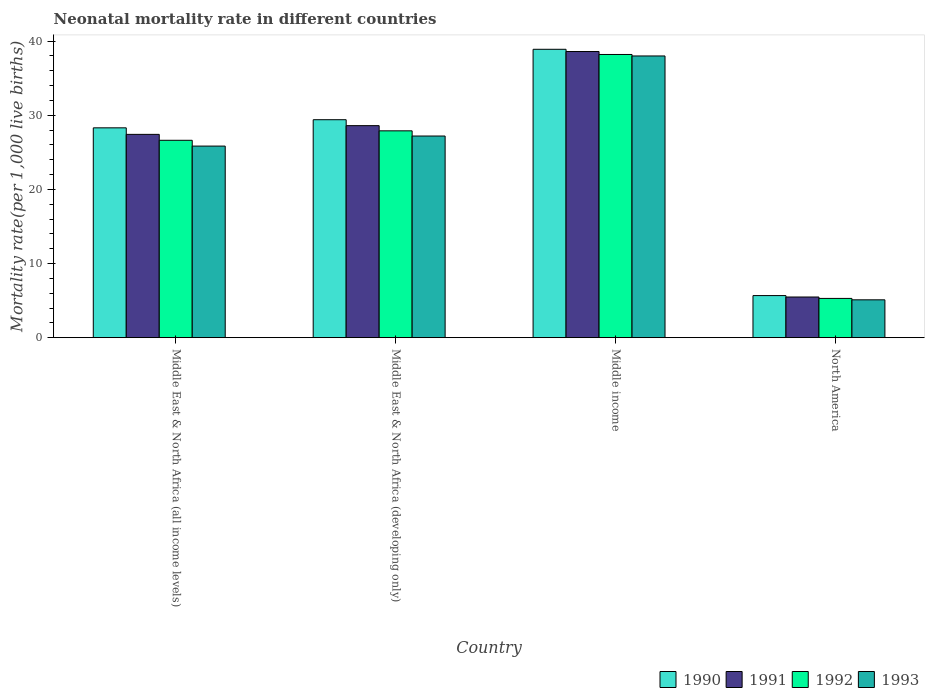How many different coloured bars are there?
Keep it short and to the point. 4. How many groups of bars are there?
Offer a very short reply. 4. Are the number of bars on each tick of the X-axis equal?
Ensure brevity in your answer.  Yes. How many bars are there on the 1st tick from the right?
Make the answer very short. 4. In how many cases, is the number of bars for a given country not equal to the number of legend labels?
Offer a very short reply. 0. What is the neonatal mortality rate in 1991 in Middle East & North Africa (developing only)?
Give a very brief answer. 28.6. Across all countries, what is the minimum neonatal mortality rate in 1992?
Your answer should be compact. 5.29. What is the total neonatal mortality rate in 1990 in the graph?
Offer a very short reply. 102.28. What is the difference between the neonatal mortality rate in 1992 in Middle East & North Africa (developing only) and that in Middle income?
Offer a terse response. -10.3. What is the difference between the neonatal mortality rate in 1990 in Middle East & North Africa (developing only) and the neonatal mortality rate in 1991 in North America?
Provide a short and direct response. 23.91. What is the average neonatal mortality rate in 1990 per country?
Offer a terse response. 25.57. What is the difference between the neonatal mortality rate of/in 1991 and neonatal mortality rate of/in 1993 in Middle East & North Africa (all income levels)?
Provide a short and direct response. 1.58. In how many countries, is the neonatal mortality rate in 1991 greater than 8?
Offer a very short reply. 3. What is the ratio of the neonatal mortality rate in 1991 in Middle East & North Africa (developing only) to that in North America?
Provide a succinct answer. 5.21. Is the neonatal mortality rate in 1991 in Middle East & North Africa (all income levels) less than that in Middle income?
Your answer should be compact. Yes. What is the difference between the highest and the second highest neonatal mortality rate in 1993?
Ensure brevity in your answer.  -1.36. What is the difference between the highest and the lowest neonatal mortality rate in 1991?
Make the answer very short. 33.11. Is it the case that in every country, the sum of the neonatal mortality rate in 1992 and neonatal mortality rate in 1990 is greater than the neonatal mortality rate in 1993?
Give a very brief answer. Yes. How many bars are there?
Give a very brief answer. 16. Are all the bars in the graph horizontal?
Make the answer very short. No. How many countries are there in the graph?
Offer a very short reply. 4. What is the difference between two consecutive major ticks on the Y-axis?
Ensure brevity in your answer.  10. Does the graph contain any zero values?
Your answer should be very brief. No. Does the graph contain grids?
Provide a succinct answer. No. Where does the legend appear in the graph?
Your answer should be very brief. Bottom right. How many legend labels are there?
Ensure brevity in your answer.  4. How are the legend labels stacked?
Make the answer very short. Horizontal. What is the title of the graph?
Offer a very short reply. Neonatal mortality rate in different countries. Does "1997" appear as one of the legend labels in the graph?
Your response must be concise. No. What is the label or title of the Y-axis?
Offer a terse response. Mortality rate(per 1,0 live births). What is the Mortality rate(per 1,000 live births) in 1990 in Middle East & North Africa (all income levels)?
Ensure brevity in your answer.  28.31. What is the Mortality rate(per 1,000 live births) in 1991 in Middle East & North Africa (all income levels)?
Keep it short and to the point. 27.42. What is the Mortality rate(per 1,000 live births) of 1992 in Middle East & North Africa (all income levels)?
Your response must be concise. 26.63. What is the Mortality rate(per 1,000 live births) in 1993 in Middle East & North Africa (all income levels)?
Provide a succinct answer. 25.84. What is the Mortality rate(per 1,000 live births) of 1990 in Middle East & North Africa (developing only)?
Your answer should be very brief. 29.4. What is the Mortality rate(per 1,000 live births) in 1991 in Middle East & North Africa (developing only)?
Your answer should be very brief. 28.6. What is the Mortality rate(per 1,000 live births) of 1992 in Middle East & North Africa (developing only)?
Provide a short and direct response. 27.9. What is the Mortality rate(per 1,000 live births) in 1993 in Middle East & North Africa (developing only)?
Your answer should be very brief. 27.2. What is the Mortality rate(per 1,000 live births) in 1990 in Middle income?
Your response must be concise. 38.9. What is the Mortality rate(per 1,000 live births) in 1991 in Middle income?
Your answer should be compact. 38.6. What is the Mortality rate(per 1,000 live births) of 1992 in Middle income?
Ensure brevity in your answer.  38.2. What is the Mortality rate(per 1,000 live births) in 1993 in Middle income?
Make the answer very short. 38. What is the Mortality rate(per 1,000 live births) in 1990 in North America?
Give a very brief answer. 5.68. What is the Mortality rate(per 1,000 live births) in 1991 in North America?
Ensure brevity in your answer.  5.49. What is the Mortality rate(per 1,000 live births) in 1992 in North America?
Offer a very short reply. 5.29. What is the Mortality rate(per 1,000 live births) in 1993 in North America?
Offer a very short reply. 5.1. Across all countries, what is the maximum Mortality rate(per 1,000 live births) of 1990?
Offer a very short reply. 38.9. Across all countries, what is the maximum Mortality rate(per 1,000 live births) of 1991?
Your answer should be compact. 38.6. Across all countries, what is the maximum Mortality rate(per 1,000 live births) of 1992?
Provide a succinct answer. 38.2. Across all countries, what is the minimum Mortality rate(per 1,000 live births) of 1990?
Keep it short and to the point. 5.68. Across all countries, what is the minimum Mortality rate(per 1,000 live births) of 1991?
Offer a very short reply. 5.49. Across all countries, what is the minimum Mortality rate(per 1,000 live births) in 1992?
Keep it short and to the point. 5.29. Across all countries, what is the minimum Mortality rate(per 1,000 live births) in 1993?
Your answer should be compact. 5.1. What is the total Mortality rate(per 1,000 live births) in 1990 in the graph?
Provide a short and direct response. 102.28. What is the total Mortality rate(per 1,000 live births) of 1991 in the graph?
Offer a terse response. 100.11. What is the total Mortality rate(per 1,000 live births) of 1992 in the graph?
Your response must be concise. 98.02. What is the total Mortality rate(per 1,000 live births) in 1993 in the graph?
Offer a very short reply. 96.15. What is the difference between the Mortality rate(per 1,000 live births) in 1990 in Middle East & North Africa (all income levels) and that in Middle East & North Africa (developing only)?
Your answer should be very brief. -1.09. What is the difference between the Mortality rate(per 1,000 live births) of 1991 in Middle East & North Africa (all income levels) and that in Middle East & North Africa (developing only)?
Give a very brief answer. -1.18. What is the difference between the Mortality rate(per 1,000 live births) in 1992 in Middle East & North Africa (all income levels) and that in Middle East & North Africa (developing only)?
Keep it short and to the point. -1.27. What is the difference between the Mortality rate(per 1,000 live births) of 1993 in Middle East & North Africa (all income levels) and that in Middle East & North Africa (developing only)?
Make the answer very short. -1.36. What is the difference between the Mortality rate(per 1,000 live births) of 1990 in Middle East & North Africa (all income levels) and that in Middle income?
Make the answer very short. -10.59. What is the difference between the Mortality rate(per 1,000 live births) in 1991 in Middle East & North Africa (all income levels) and that in Middle income?
Your response must be concise. -11.18. What is the difference between the Mortality rate(per 1,000 live births) of 1992 in Middle East & North Africa (all income levels) and that in Middle income?
Ensure brevity in your answer.  -11.57. What is the difference between the Mortality rate(per 1,000 live births) of 1993 in Middle East & North Africa (all income levels) and that in Middle income?
Make the answer very short. -12.16. What is the difference between the Mortality rate(per 1,000 live births) in 1990 in Middle East & North Africa (all income levels) and that in North America?
Ensure brevity in your answer.  22.63. What is the difference between the Mortality rate(per 1,000 live births) in 1991 in Middle East & North Africa (all income levels) and that in North America?
Offer a terse response. 21.94. What is the difference between the Mortality rate(per 1,000 live births) of 1992 in Middle East & North Africa (all income levels) and that in North America?
Provide a succinct answer. 21.33. What is the difference between the Mortality rate(per 1,000 live births) in 1993 in Middle East & North Africa (all income levels) and that in North America?
Your answer should be very brief. 20.74. What is the difference between the Mortality rate(per 1,000 live births) of 1990 in Middle East & North Africa (developing only) and that in Middle income?
Your answer should be compact. -9.5. What is the difference between the Mortality rate(per 1,000 live births) of 1991 in Middle East & North Africa (developing only) and that in Middle income?
Give a very brief answer. -10. What is the difference between the Mortality rate(per 1,000 live births) in 1992 in Middle East & North Africa (developing only) and that in Middle income?
Keep it short and to the point. -10.3. What is the difference between the Mortality rate(per 1,000 live births) in 1990 in Middle East & North Africa (developing only) and that in North America?
Offer a very short reply. 23.72. What is the difference between the Mortality rate(per 1,000 live births) in 1991 in Middle East & North Africa (developing only) and that in North America?
Offer a very short reply. 23.11. What is the difference between the Mortality rate(per 1,000 live births) of 1992 in Middle East & North Africa (developing only) and that in North America?
Your answer should be compact. 22.61. What is the difference between the Mortality rate(per 1,000 live births) of 1993 in Middle East & North Africa (developing only) and that in North America?
Keep it short and to the point. 22.1. What is the difference between the Mortality rate(per 1,000 live births) of 1990 in Middle income and that in North America?
Make the answer very short. 33.22. What is the difference between the Mortality rate(per 1,000 live births) in 1991 in Middle income and that in North America?
Offer a very short reply. 33.11. What is the difference between the Mortality rate(per 1,000 live births) of 1992 in Middle income and that in North America?
Make the answer very short. 32.91. What is the difference between the Mortality rate(per 1,000 live births) of 1993 in Middle income and that in North America?
Your response must be concise. 32.9. What is the difference between the Mortality rate(per 1,000 live births) in 1990 in Middle East & North Africa (all income levels) and the Mortality rate(per 1,000 live births) in 1991 in Middle East & North Africa (developing only)?
Your response must be concise. -0.29. What is the difference between the Mortality rate(per 1,000 live births) of 1990 in Middle East & North Africa (all income levels) and the Mortality rate(per 1,000 live births) of 1992 in Middle East & North Africa (developing only)?
Offer a terse response. 0.41. What is the difference between the Mortality rate(per 1,000 live births) of 1990 in Middle East & North Africa (all income levels) and the Mortality rate(per 1,000 live births) of 1993 in Middle East & North Africa (developing only)?
Ensure brevity in your answer.  1.11. What is the difference between the Mortality rate(per 1,000 live births) in 1991 in Middle East & North Africa (all income levels) and the Mortality rate(per 1,000 live births) in 1992 in Middle East & North Africa (developing only)?
Provide a short and direct response. -0.48. What is the difference between the Mortality rate(per 1,000 live births) of 1991 in Middle East & North Africa (all income levels) and the Mortality rate(per 1,000 live births) of 1993 in Middle East & North Africa (developing only)?
Provide a short and direct response. 0.22. What is the difference between the Mortality rate(per 1,000 live births) in 1992 in Middle East & North Africa (all income levels) and the Mortality rate(per 1,000 live births) in 1993 in Middle East & North Africa (developing only)?
Your response must be concise. -0.57. What is the difference between the Mortality rate(per 1,000 live births) in 1990 in Middle East & North Africa (all income levels) and the Mortality rate(per 1,000 live births) in 1991 in Middle income?
Provide a short and direct response. -10.29. What is the difference between the Mortality rate(per 1,000 live births) of 1990 in Middle East & North Africa (all income levels) and the Mortality rate(per 1,000 live births) of 1992 in Middle income?
Offer a very short reply. -9.89. What is the difference between the Mortality rate(per 1,000 live births) in 1990 in Middle East & North Africa (all income levels) and the Mortality rate(per 1,000 live births) in 1993 in Middle income?
Give a very brief answer. -9.69. What is the difference between the Mortality rate(per 1,000 live births) in 1991 in Middle East & North Africa (all income levels) and the Mortality rate(per 1,000 live births) in 1992 in Middle income?
Make the answer very short. -10.78. What is the difference between the Mortality rate(per 1,000 live births) of 1991 in Middle East & North Africa (all income levels) and the Mortality rate(per 1,000 live births) of 1993 in Middle income?
Your answer should be compact. -10.58. What is the difference between the Mortality rate(per 1,000 live births) of 1992 in Middle East & North Africa (all income levels) and the Mortality rate(per 1,000 live births) of 1993 in Middle income?
Make the answer very short. -11.37. What is the difference between the Mortality rate(per 1,000 live births) of 1990 in Middle East & North Africa (all income levels) and the Mortality rate(per 1,000 live births) of 1991 in North America?
Offer a terse response. 22.82. What is the difference between the Mortality rate(per 1,000 live births) of 1990 in Middle East & North Africa (all income levels) and the Mortality rate(per 1,000 live births) of 1992 in North America?
Provide a short and direct response. 23.01. What is the difference between the Mortality rate(per 1,000 live births) of 1990 in Middle East & North Africa (all income levels) and the Mortality rate(per 1,000 live births) of 1993 in North America?
Provide a short and direct response. 23.2. What is the difference between the Mortality rate(per 1,000 live births) in 1991 in Middle East & North Africa (all income levels) and the Mortality rate(per 1,000 live births) in 1992 in North America?
Your answer should be compact. 22.13. What is the difference between the Mortality rate(per 1,000 live births) in 1991 in Middle East & North Africa (all income levels) and the Mortality rate(per 1,000 live births) in 1993 in North America?
Provide a short and direct response. 22.32. What is the difference between the Mortality rate(per 1,000 live births) in 1992 in Middle East & North Africa (all income levels) and the Mortality rate(per 1,000 live births) in 1993 in North America?
Your answer should be compact. 21.52. What is the difference between the Mortality rate(per 1,000 live births) of 1990 in Middle East & North Africa (developing only) and the Mortality rate(per 1,000 live births) of 1991 in Middle income?
Your answer should be very brief. -9.2. What is the difference between the Mortality rate(per 1,000 live births) of 1990 in Middle East & North Africa (developing only) and the Mortality rate(per 1,000 live births) of 1992 in Middle income?
Your answer should be compact. -8.8. What is the difference between the Mortality rate(per 1,000 live births) in 1991 in Middle East & North Africa (developing only) and the Mortality rate(per 1,000 live births) in 1992 in Middle income?
Your answer should be compact. -9.6. What is the difference between the Mortality rate(per 1,000 live births) in 1990 in Middle East & North Africa (developing only) and the Mortality rate(per 1,000 live births) in 1991 in North America?
Your response must be concise. 23.91. What is the difference between the Mortality rate(per 1,000 live births) in 1990 in Middle East & North Africa (developing only) and the Mortality rate(per 1,000 live births) in 1992 in North America?
Keep it short and to the point. 24.11. What is the difference between the Mortality rate(per 1,000 live births) in 1990 in Middle East & North Africa (developing only) and the Mortality rate(per 1,000 live births) in 1993 in North America?
Keep it short and to the point. 24.3. What is the difference between the Mortality rate(per 1,000 live births) in 1991 in Middle East & North Africa (developing only) and the Mortality rate(per 1,000 live births) in 1992 in North America?
Make the answer very short. 23.31. What is the difference between the Mortality rate(per 1,000 live births) in 1991 in Middle East & North Africa (developing only) and the Mortality rate(per 1,000 live births) in 1993 in North America?
Your answer should be very brief. 23.5. What is the difference between the Mortality rate(per 1,000 live births) in 1992 in Middle East & North Africa (developing only) and the Mortality rate(per 1,000 live births) in 1993 in North America?
Keep it short and to the point. 22.8. What is the difference between the Mortality rate(per 1,000 live births) in 1990 in Middle income and the Mortality rate(per 1,000 live births) in 1991 in North America?
Offer a very short reply. 33.41. What is the difference between the Mortality rate(per 1,000 live births) of 1990 in Middle income and the Mortality rate(per 1,000 live births) of 1992 in North America?
Ensure brevity in your answer.  33.61. What is the difference between the Mortality rate(per 1,000 live births) in 1990 in Middle income and the Mortality rate(per 1,000 live births) in 1993 in North America?
Give a very brief answer. 33.8. What is the difference between the Mortality rate(per 1,000 live births) in 1991 in Middle income and the Mortality rate(per 1,000 live births) in 1992 in North America?
Give a very brief answer. 33.31. What is the difference between the Mortality rate(per 1,000 live births) in 1991 in Middle income and the Mortality rate(per 1,000 live births) in 1993 in North America?
Give a very brief answer. 33.5. What is the difference between the Mortality rate(per 1,000 live births) in 1992 in Middle income and the Mortality rate(per 1,000 live births) in 1993 in North America?
Offer a terse response. 33.1. What is the average Mortality rate(per 1,000 live births) of 1990 per country?
Make the answer very short. 25.57. What is the average Mortality rate(per 1,000 live births) of 1991 per country?
Your answer should be very brief. 25.03. What is the average Mortality rate(per 1,000 live births) of 1992 per country?
Make the answer very short. 24.5. What is the average Mortality rate(per 1,000 live births) in 1993 per country?
Give a very brief answer. 24.04. What is the difference between the Mortality rate(per 1,000 live births) in 1990 and Mortality rate(per 1,000 live births) in 1991 in Middle East & North Africa (all income levels)?
Provide a short and direct response. 0.88. What is the difference between the Mortality rate(per 1,000 live births) of 1990 and Mortality rate(per 1,000 live births) of 1992 in Middle East & North Africa (all income levels)?
Ensure brevity in your answer.  1.68. What is the difference between the Mortality rate(per 1,000 live births) in 1990 and Mortality rate(per 1,000 live births) in 1993 in Middle East & North Africa (all income levels)?
Provide a succinct answer. 2.46. What is the difference between the Mortality rate(per 1,000 live births) in 1991 and Mortality rate(per 1,000 live births) in 1992 in Middle East & North Africa (all income levels)?
Provide a succinct answer. 0.8. What is the difference between the Mortality rate(per 1,000 live births) of 1991 and Mortality rate(per 1,000 live births) of 1993 in Middle East & North Africa (all income levels)?
Offer a very short reply. 1.58. What is the difference between the Mortality rate(per 1,000 live births) of 1992 and Mortality rate(per 1,000 live births) of 1993 in Middle East & North Africa (all income levels)?
Offer a terse response. 0.78. What is the difference between the Mortality rate(per 1,000 live births) in 1991 and Mortality rate(per 1,000 live births) in 1992 in Middle East & North Africa (developing only)?
Your answer should be compact. 0.7. What is the difference between the Mortality rate(per 1,000 live births) of 1990 and Mortality rate(per 1,000 live births) of 1991 in Middle income?
Ensure brevity in your answer.  0.3. What is the difference between the Mortality rate(per 1,000 live births) in 1991 and Mortality rate(per 1,000 live births) in 1992 in Middle income?
Provide a succinct answer. 0.4. What is the difference between the Mortality rate(per 1,000 live births) of 1991 and Mortality rate(per 1,000 live births) of 1993 in Middle income?
Make the answer very short. 0.6. What is the difference between the Mortality rate(per 1,000 live births) in 1992 and Mortality rate(per 1,000 live births) in 1993 in Middle income?
Give a very brief answer. 0.2. What is the difference between the Mortality rate(per 1,000 live births) in 1990 and Mortality rate(per 1,000 live births) in 1991 in North America?
Provide a succinct answer. 0.19. What is the difference between the Mortality rate(per 1,000 live births) of 1990 and Mortality rate(per 1,000 live births) of 1992 in North America?
Offer a very short reply. 0.38. What is the difference between the Mortality rate(per 1,000 live births) in 1990 and Mortality rate(per 1,000 live births) in 1993 in North America?
Provide a short and direct response. 0.57. What is the difference between the Mortality rate(per 1,000 live births) of 1991 and Mortality rate(per 1,000 live births) of 1992 in North America?
Your answer should be compact. 0.19. What is the difference between the Mortality rate(per 1,000 live births) of 1991 and Mortality rate(per 1,000 live births) of 1993 in North America?
Ensure brevity in your answer.  0.38. What is the difference between the Mortality rate(per 1,000 live births) in 1992 and Mortality rate(per 1,000 live births) in 1993 in North America?
Your answer should be compact. 0.19. What is the ratio of the Mortality rate(per 1,000 live births) in 1990 in Middle East & North Africa (all income levels) to that in Middle East & North Africa (developing only)?
Offer a terse response. 0.96. What is the ratio of the Mortality rate(per 1,000 live births) of 1991 in Middle East & North Africa (all income levels) to that in Middle East & North Africa (developing only)?
Keep it short and to the point. 0.96. What is the ratio of the Mortality rate(per 1,000 live births) in 1992 in Middle East & North Africa (all income levels) to that in Middle East & North Africa (developing only)?
Your response must be concise. 0.95. What is the ratio of the Mortality rate(per 1,000 live births) in 1993 in Middle East & North Africa (all income levels) to that in Middle East & North Africa (developing only)?
Ensure brevity in your answer.  0.95. What is the ratio of the Mortality rate(per 1,000 live births) in 1990 in Middle East & North Africa (all income levels) to that in Middle income?
Offer a very short reply. 0.73. What is the ratio of the Mortality rate(per 1,000 live births) of 1991 in Middle East & North Africa (all income levels) to that in Middle income?
Your answer should be very brief. 0.71. What is the ratio of the Mortality rate(per 1,000 live births) of 1992 in Middle East & North Africa (all income levels) to that in Middle income?
Ensure brevity in your answer.  0.7. What is the ratio of the Mortality rate(per 1,000 live births) in 1993 in Middle East & North Africa (all income levels) to that in Middle income?
Ensure brevity in your answer.  0.68. What is the ratio of the Mortality rate(per 1,000 live births) in 1990 in Middle East & North Africa (all income levels) to that in North America?
Your response must be concise. 4.99. What is the ratio of the Mortality rate(per 1,000 live births) in 1991 in Middle East & North Africa (all income levels) to that in North America?
Your answer should be very brief. 5. What is the ratio of the Mortality rate(per 1,000 live births) in 1992 in Middle East & North Africa (all income levels) to that in North America?
Keep it short and to the point. 5.03. What is the ratio of the Mortality rate(per 1,000 live births) of 1993 in Middle East & North Africa (all income levels) to that in North America?
Offer a terse response. 5.06. What is the ratio of the Mortality rate(per 1,000 live births) of 1990 in Middle East & North Africa (developing only) to that in Middle income?
Your response must be concise. 0.76. What is the ratio of the Mortality rate(per 1,000 live births) of 1991 in Middle East & North Africa (developing only) to that in Middle income?
Provide a succinct answer. 0.74. What is the ratio of the Mortality rate(per 1,000 live births) of 1992 in Middle East & North Africa (developing only) to that in Middle income?
Offer a very short reply. 0.73. What is the ratio of the Mortality rate(per 1,000 live births) in 1993 in Middle East & North Africa (developing only) to that in Middle income?
Offer a terse response. 0.72. What is the ratio of the Mortality rate(per 1,000 live births) in 1990 in Middle East & North Africa (developing only) to that in North America?
Your answer should be very brief. 5.18. What is the ratio of the Mortality rate(per 1,000 live births) in 1991 in Middle East & North Africa (developing only) to that in North America?
Provide a succinct answer. 5.21. What is the ratio of the Mortality rate(per 1,000 live births) in 1992 in Middle East & North Africa (developing only) to that in North America?
Keep it short and to the point. 5.27. What is the ratio of the Mortality rate(per 1,000 live births) of 1993 in Middle East & North Africa (developing only) to that in North America?
Your answer should be very brief. 5.33. What is the ratio of the Mortality rate(per 1,000 live births) in 1990 in Middle income to that in North America?
Give a very brief answer. 6.85. What is the ratio of the Mortality rate(per 1,000 live births) of 1991 in Middle income to that in North America?
Ensure brevity in your answer.  7.04. What is the ratio of the Mortality rate(per 1,000 live births) in 1992 in Middle income to that in North America?
Your answer should be very brief. 7.21. What is the ratio of the Mortality rate(per 1,000 live births) of 1993 in Middle income to that in North America?
Offer a terse response. 7.45. What is the difference between the highest and the second highest Mortality rate(per 1,000 live births) in 1990?
Ensure brevity in your answer.  9.5. What is the difference between the highest and the second highest Mortality rate(per 1,000 live births) of 1991?
Ensure brevity in your answer.  10. What is the difference between the highest and the lowest Mortality rate(per 1,000 live births) in 1990?
Provide a short and direct response. 33.22. What is the difference between the highest and the lowest Mortality rate(per 1,000 live births) of 1991?
Your answer should be very brief. 33.11. What is the difference between the highest and the lowest Mortality rate(per 1,000 live births) of 1992?
Provide a short and direct response. 32.91. What is the difference between the highest and the lowest Mortality rate(per 1,000 live births) of 1993?
Provide a succinct answer. 32.9. 